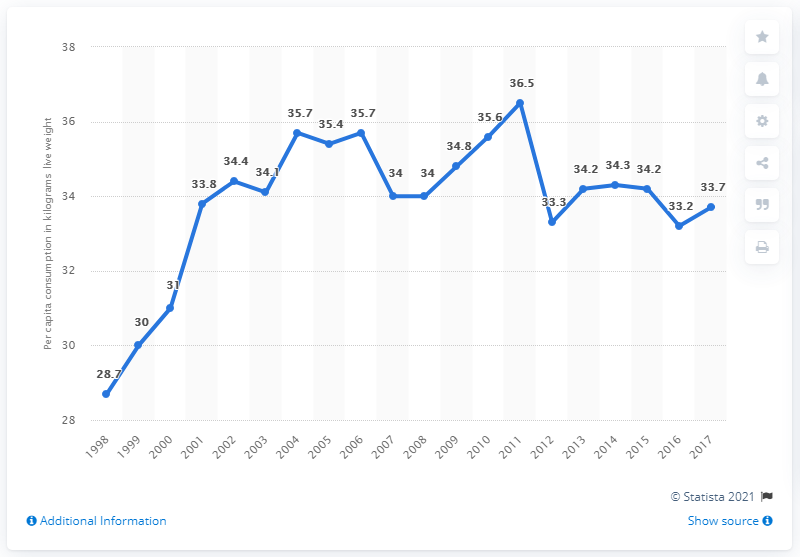List a handful of essential elements in this visual. In 2011, the French consumed the highest amount of seafood among all the years. The peak value of the graph is 36.5. In the years 2005 to 2007, the median value was 35.4. 